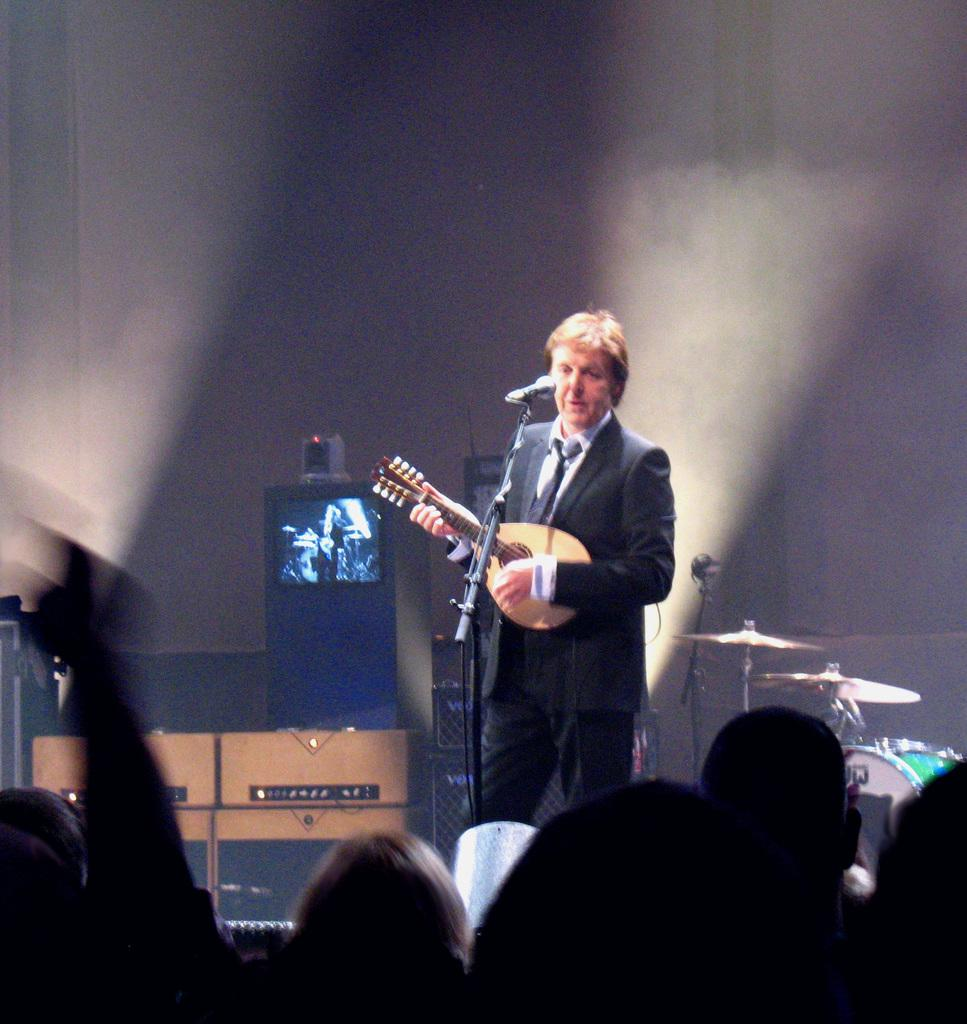What is the man in the image doing? The man is playing a guitar in the image. What object is in front of the man? There is a microphone in the image, and the man is in front of it. Where is the man performing? The man is on a stage in the image. What other musical instruments can be seen in the image? There are other musical instruments in the image, but their specific types are not mentioned. Are there any other people present in the image? Yes, there are people in the image. What type of hat is the man wearing in the image? There is no mention of a hat in the image, so it cannot be determined if the man is wearing one. 